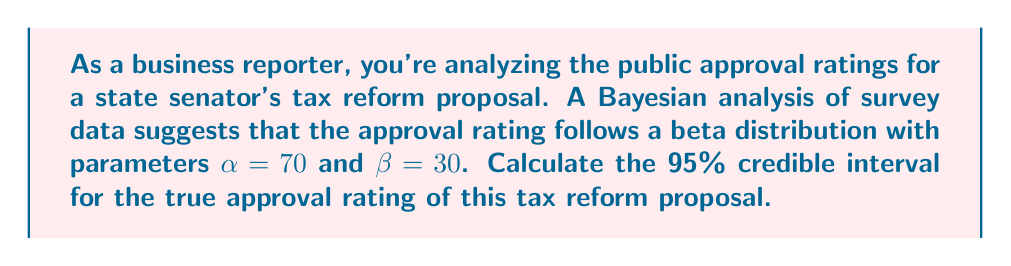Show me your answer to this math problem. To solve this problem, we'll follow these steps:

1) The beta distribution is commonly used for modeling proportions or probabilities, making it suitable for approval ratings.

2) For a beta distribution with parameters $\alpha$ and $\beta$, the mean is given by:

   $$\mu = \frac{\alpha}{\alpha + \beta}$$

3) The variance is:

   $$\sigma^2 = \frac{\alpha\beta}{(\alpha + \beta)^2(\alpha + \beta + 1)}$$

4) For a 95% credible interval, we need to find the 2.5th and 97.5th percentiles of the beta distribution.

5) There's no simple closed-form expression for these percentiles, so we'll use the beta.ppf function from a statistical library (e.g., SciPy in Python) to compute them.

6) Using a statistical software, we can calculate:

   2.5th percentile: 0.6079
   97.5th percentile: 0.7639

7) Therefore, the 95% credible interval is (0.6079, 0.7639).

This means we can be 95% confident that the true approval rating for the tax reform proposal lies between 60.79% and 76.39%.

For the business reporter, this credible interval provides a range of plausible values for the public approval of the state senator's tax reform proposal, accounting for uncertainty in the data.
Answer: The 95% credible interval for the true approval rating of the tax reform proposal is (0.6079, 0.7639) or (60.79%, 76.39%). 